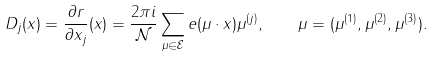<formula> <loc_0><loc_0><loc_500><loc_500>D _ { j } ( x ) = \frac { \partial r } { \partial x _ { j } } ( x ) = \frac { 2 \pi i } { \mathcal { N } } \sum _ { \mu \in \mathcal { E } } e ( \mu \cdot x ) \mu ^ { ( j ) } , \quad \mu = ( \mu ^ { ( 1 ) } , \mu ^ { ( 2 ) } , \mu ^ { ( 3 ) } ) .</formula> 